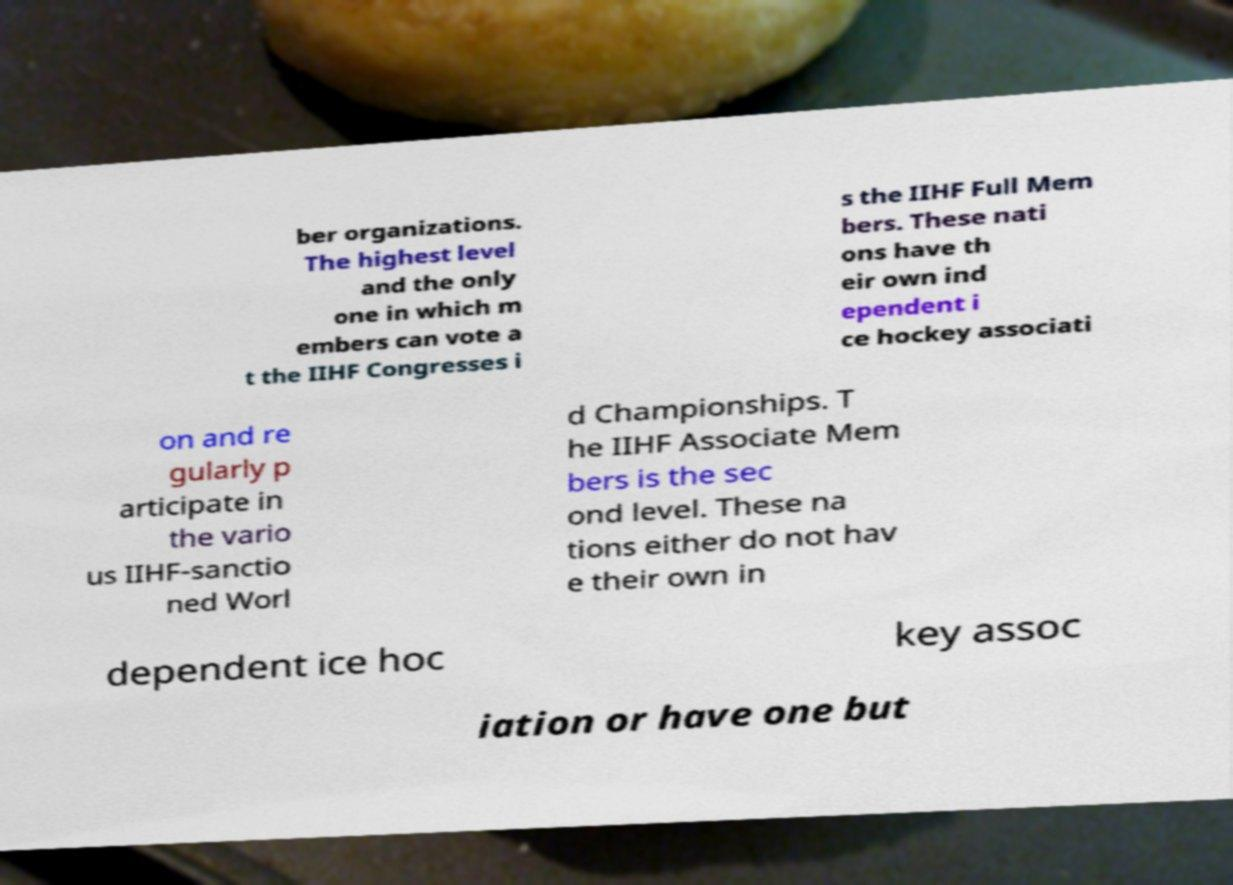I need the written content from this picture converted into text. Can you do that? ber organizations. The highest level and the only one in which m embers can vote a t the IIHF Congresses i s the IIHF Full Mem bers. These nati ons have th eir own ind ependent i ce hockey associati on and re gularly p articipate in the vario us IIHF-sanctio ned Worl d Championships. T he IIHF Associate Mem bers is the sec ond level. These na tions either do not hav e their own in dependent ice hoc key assoc iation or have one but 